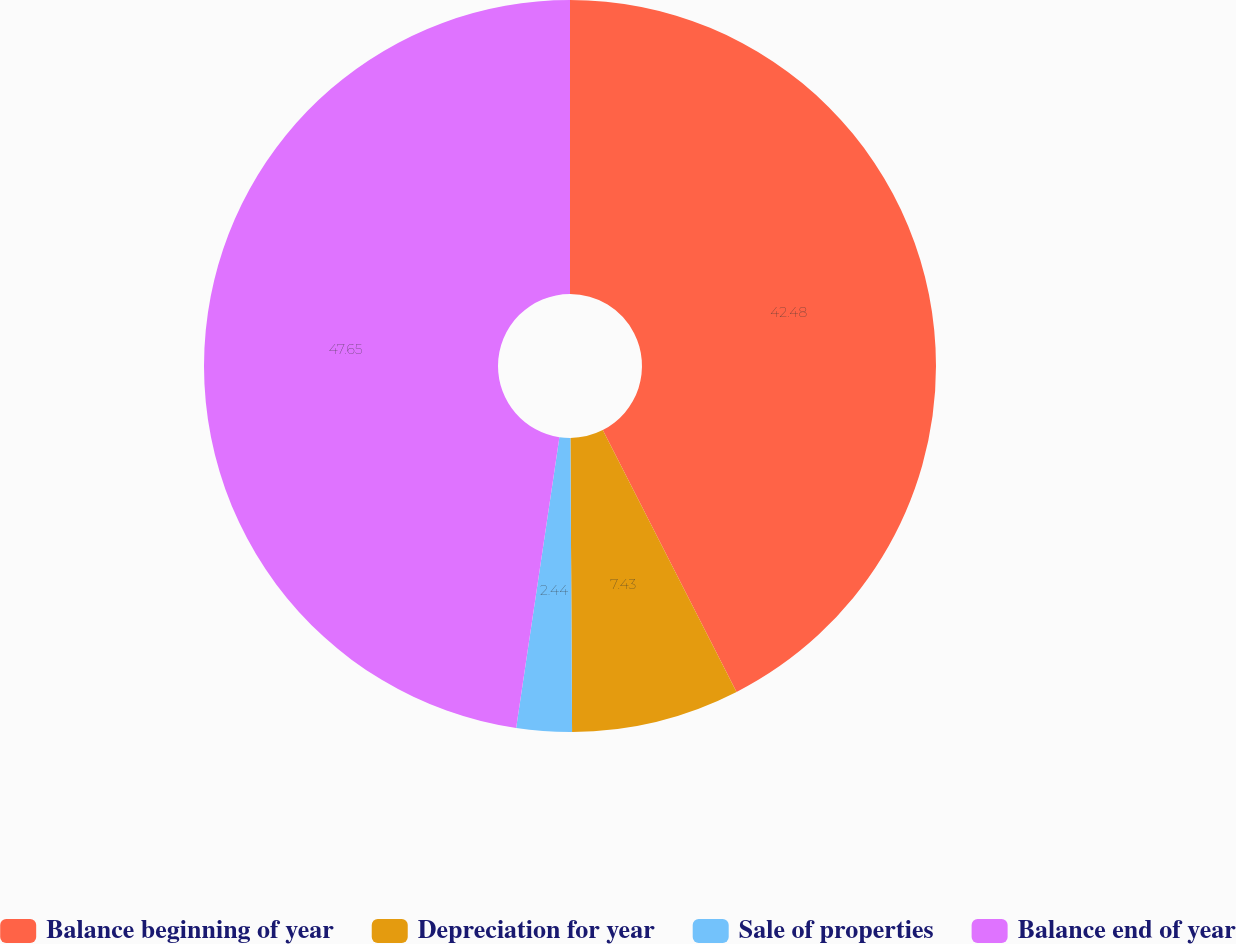Convert chart. <chart><loc_0><loc_0><loc_500><loc_500><pie_chart><fcel>Balance beginning of year<fcel>Depreciation for year<fcel>Sale of properties<fcel>Balance end of year<nl><fcel>42.48%<fcel>7.43%<fcel>2.44%<fcel>47.65%<nl></chart> 